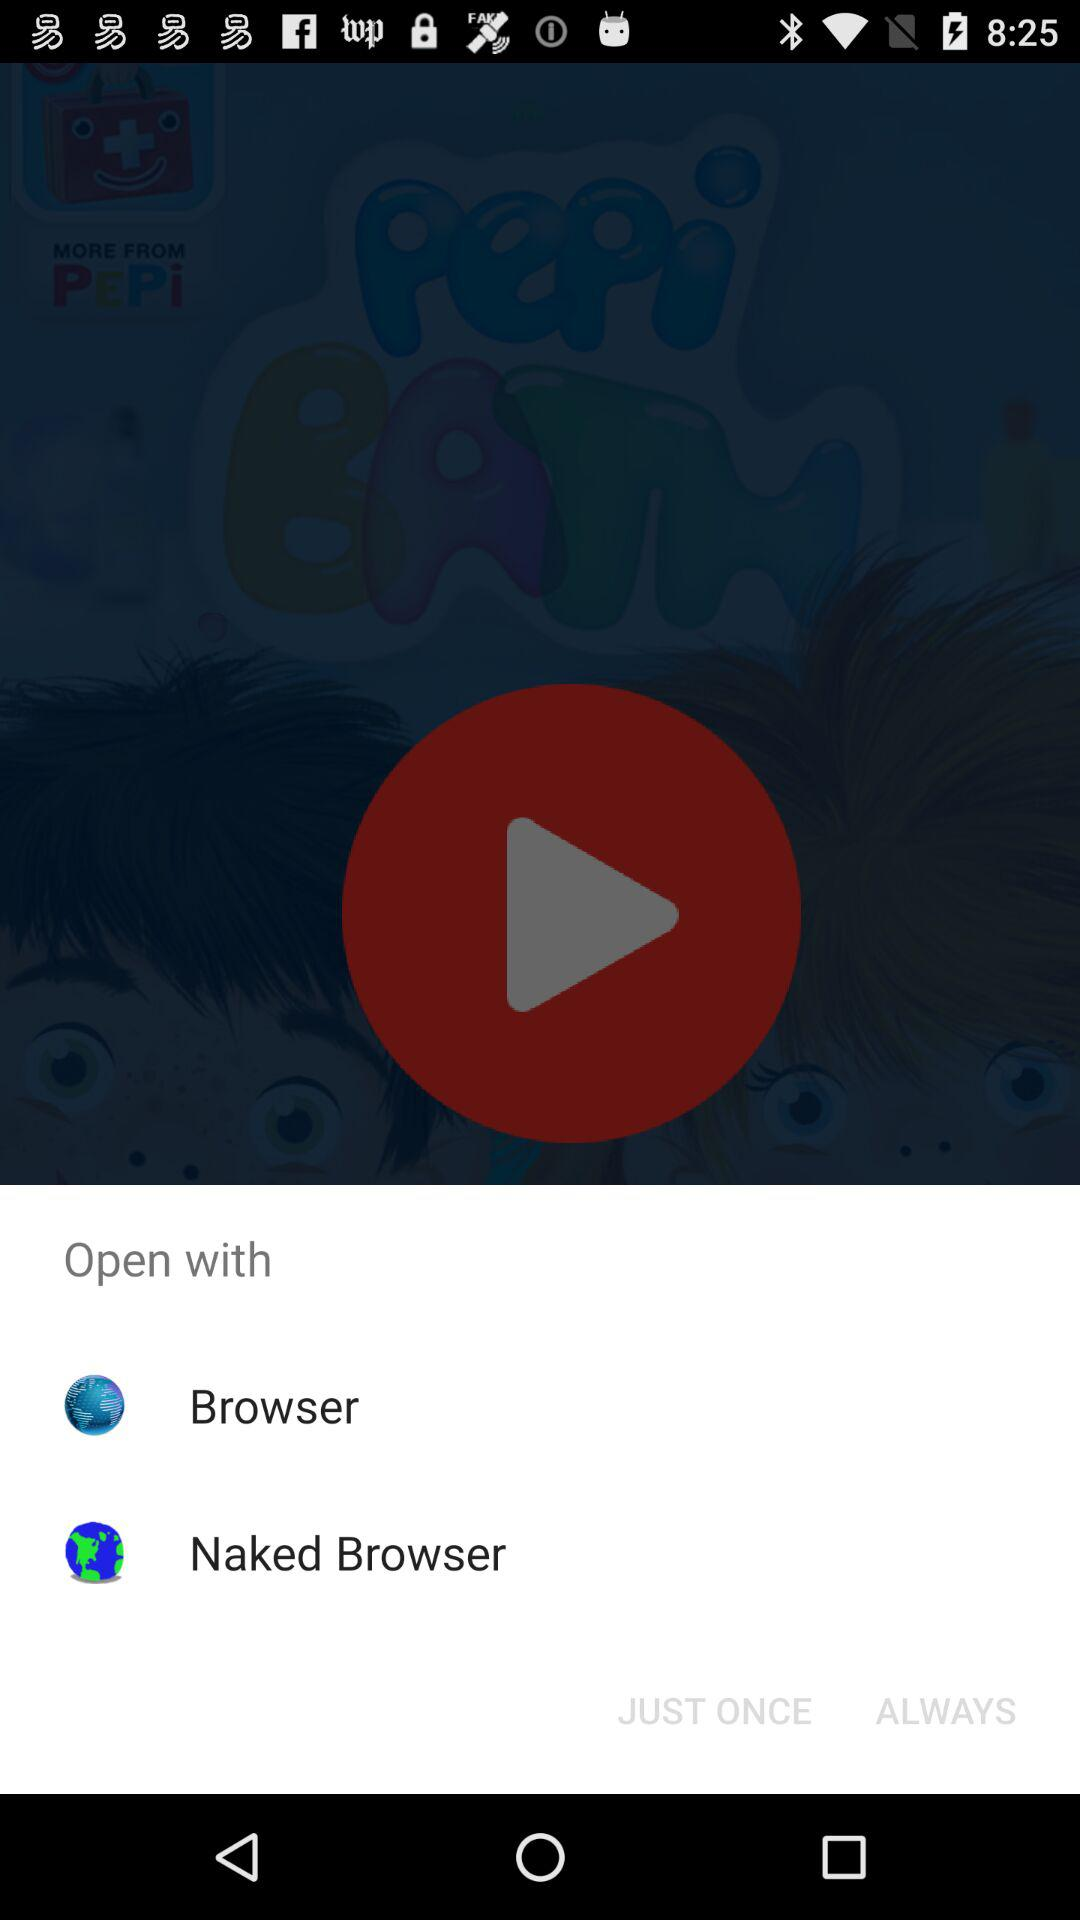What are the options to open? The options are "Browser" and "Naked Browser". 